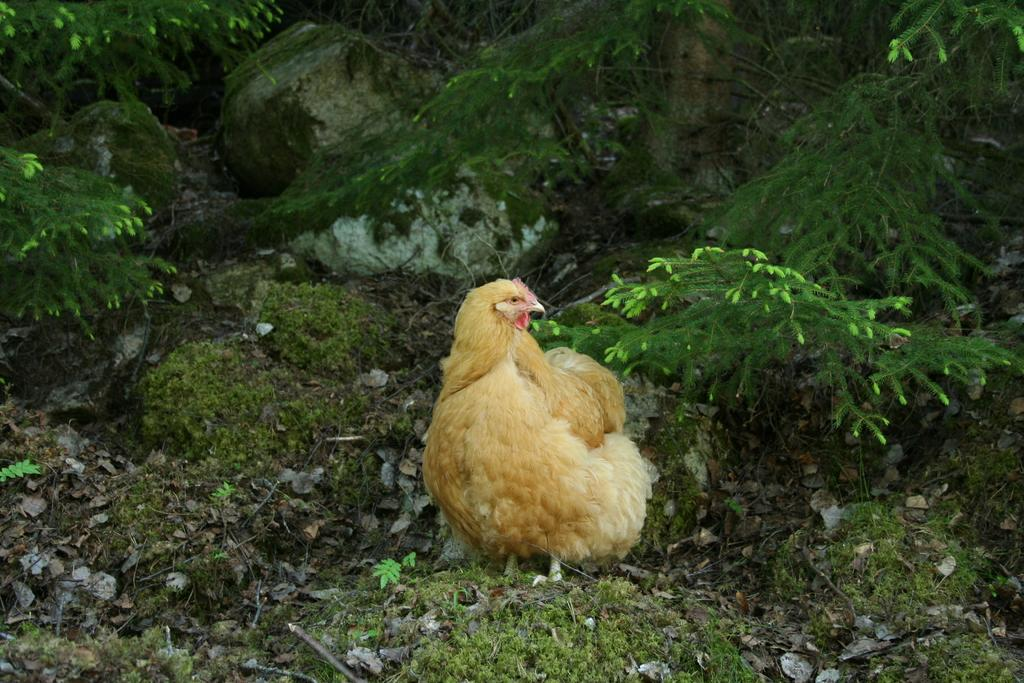What animal is present in the picture? There is a hen in the picture. What type of natural objects can be seen in the picture? There are rocks in the picture. What can be seen in the background of the picture? There are trees in the background of the picture. What type of fruit is being listed by the hen in the picture? There is no fruit or list present in the image; it features a hen and rocks with trees in the background. 